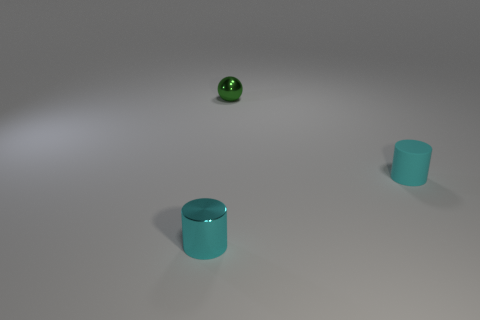Is the color of the small rubber object the same as the cylinder that is in front of the small rubber thing?
Your answer should be very brief. Yes. Is the number of small metallic objects less than the number of shiny cylinders?
Your answer should be compact. No. Is the number of shiny spheres on the left side of the cyan metallic thing greater than the number of small rubber cylinders in front of the cyan matte thing?
Ensure brevity in your answer.  No. There is a metal thing behind the rubber cylinder; how many tiny cyan cylinders are on the left side of it?
Your response must be concise. 1. There is a cylinder behind the small cyan shiny thing; is its color the same as the small shiny cylinder?
Make the answer very short. Yes. What number of objects are either brown rubber objects or cyan rubber things that are right of the green metal sphere?
Ensure brevity in your answer.  1. Do the tiny object that is right of the small green object and the thing that is in front of the small matte cylinder have the same shape?
Give a very brief answer. Yes. Are there any other things of the same color as the tiny metal ball?
Provide a succinct answer. No. There is a cyan thing that is made of the same material as the small ball; what is its shape?
Make the answer very short. Cylinder. What is the object that is both in front of the shiny sphere and left of the cyan matte thing made of?
Give a very brief answer. Metal. 